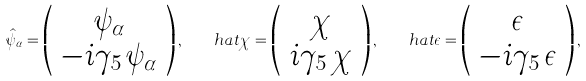<formula> <loc_0><loc_0><loc_500><loc_500>\hat { \psi } _ { \alpha } = \left ( \begin{array} { c } \psi _ { \alpha } \\ - i \gamma _ { 5 } \, { \psi } _ { \alpha } \end{array} \right ) , \quad h a t { \chi } = \left ( \begin{array} { c } { \chi } \\ i \gamma _ { 5 } \, \chi \end{array} \right ) , \quad h a t { \epsilon } = \left ( \begin{array} { c } \epsilon \\ - i \gamma _ { 5 } \, \epsilon \end{array} \right ) , \ \</formula> 